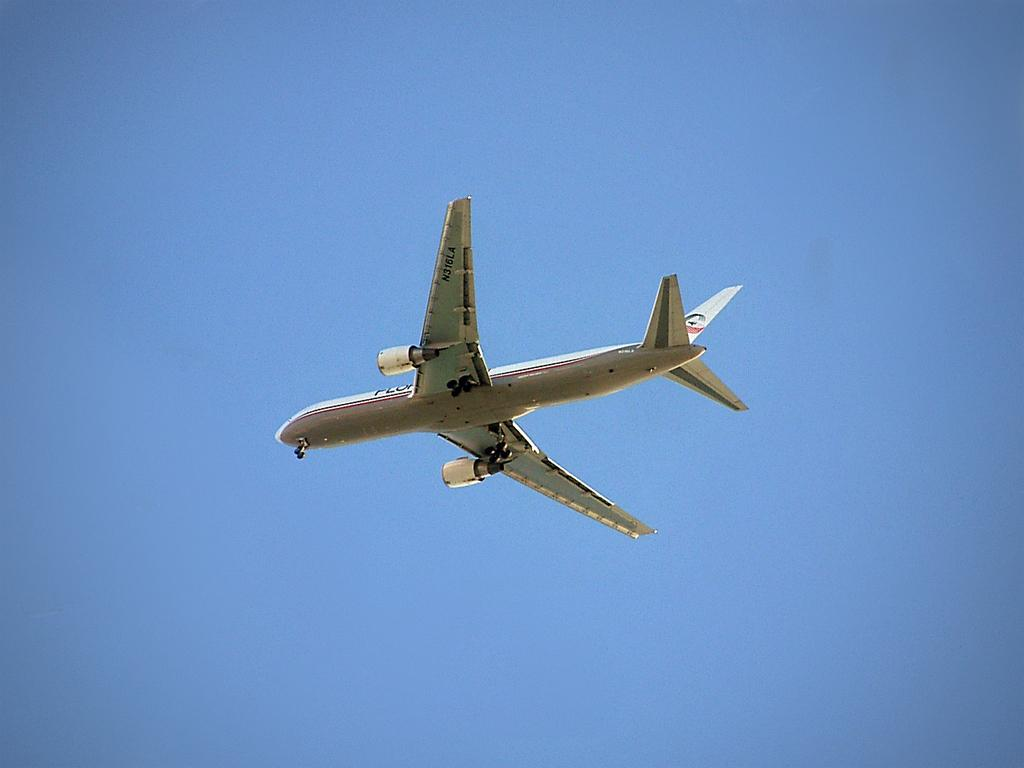What is the main subject of the image? The main subject of the image is an airplane. What is the airplane doing in the image? The airplane is flying in the image. What can be seen in the background of the image? The sky is visible in the background of the image. How many fairies are flying alongside the airplane in the image? There are no fairies present in the image; it only features an airplane flying in the sky. 